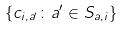Convert formula to latex. <formula><loc_0><loc_0><loc_500><loc_500>\{ c _ { i , a ^ { \prime } } \colon a ^ { \prime } \in S _ { a , i } \}</formula> 